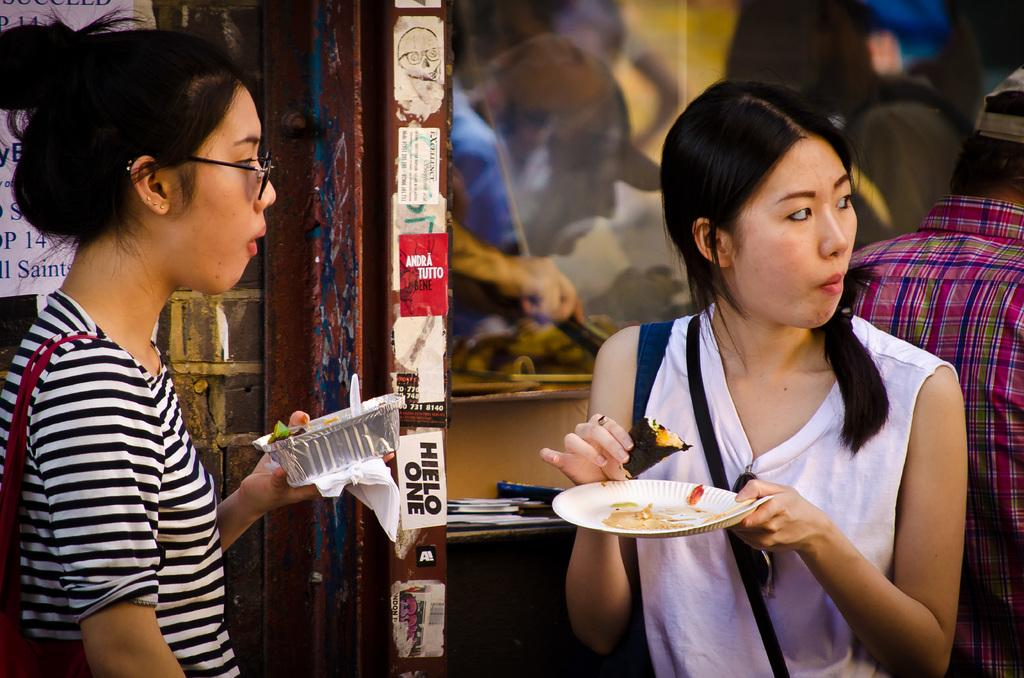How many people are present in the image? There are two ladies and one man in the image, making a total of three people. What are the ladies doing in the image? The ladies are eating food items and holding plates in their hands. Can you describe the man's position in the image? The man is standing on the right side of the image. What can be seen in the background of the image? There is a wall in the background of the image. What type of tray is the manager holding in the image? There is no tray or manager present in the image. 